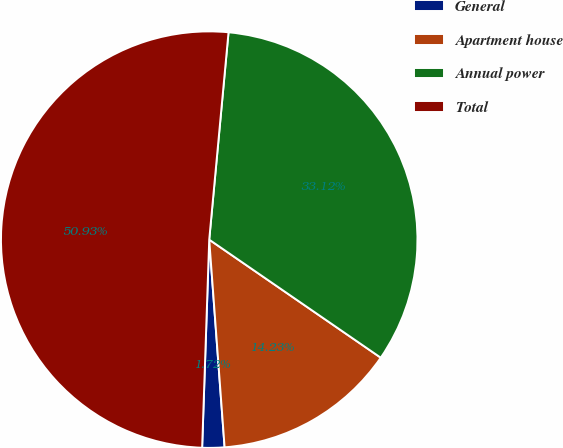Convert chart. <chart><loc_0><loc_0><loc_500><loc_500><pie_chart><fcel>General<fcel>Apartment house<fcel>Annual power<fcel>Total<nl><fcel>1.72%<fcel>14.23%<fcel>33.12%<fcel>50.94%<nl></chart> 